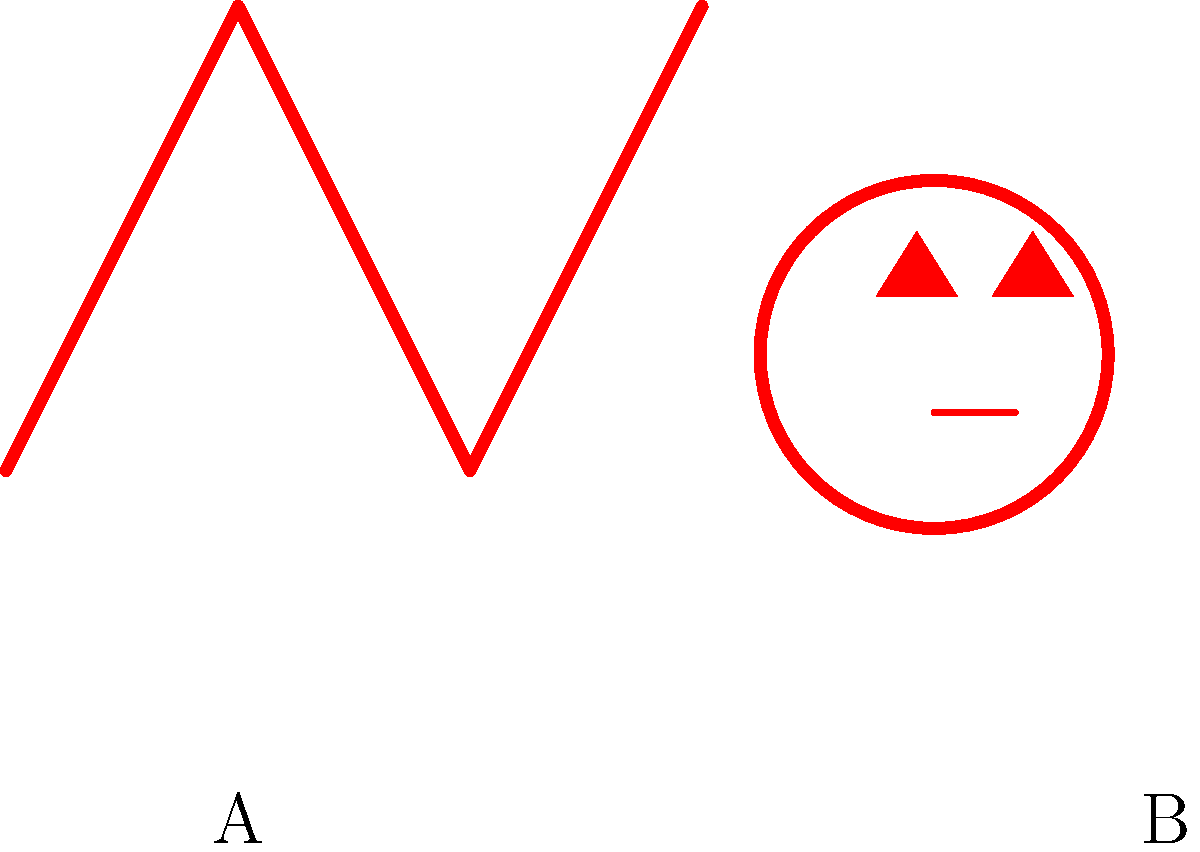In the image above, two common electrical hazard symbols are shown. Which symbol represents the danger of electric shock? To answer this question, we need to analyze the two symbols presented in the image:

1. Symbol A (on the left):
   - This symbol shows a zigzag line resembling a lightning bolt.
   - The lightning bolt is a universally recognized symbol for electricity.
   - In the context of safety symbols, a lightning bolt typically indicates the presence of high voltage or the risk of electric shock.

2. Symbol B (on the right):
   - This symbol depicts a skull-like shape.
   - The skull is commonly used to represent danger or toxicity.
   - In electrical contexts, a skull symbol usually warns of a general danger or potentially fatal hazard, but it's not specific to electric shock.

3. Comparing the symbols:
   - Symbol A (lightning bolt) is more directly related to electricity and the specific danger of electric shock.
   - Symbol B (skull) is a more general warning symbol and doesn't specifically indicate an electrical hazard.

Therefore, the symbol that represents the danger of electric shock is Symbol A, the lightning bolt.
Answer: Symbol A (lightning bolt) 